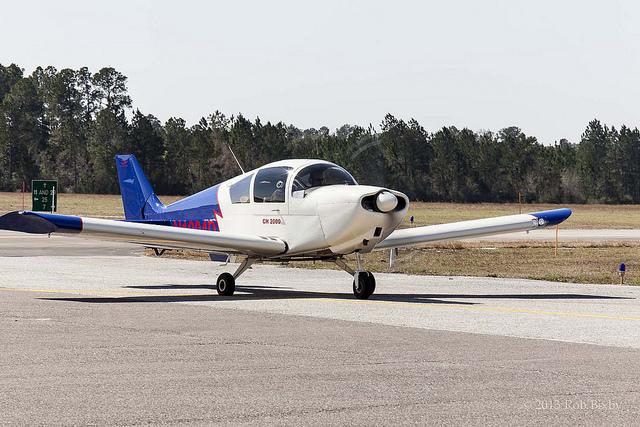What kind of plane is this?
Be succinct. Cessna. Is the plane moving while the picture was being taken?
Keep it brief. No. What color is the tail of the plane?
Give a very brief answer. Blue. 